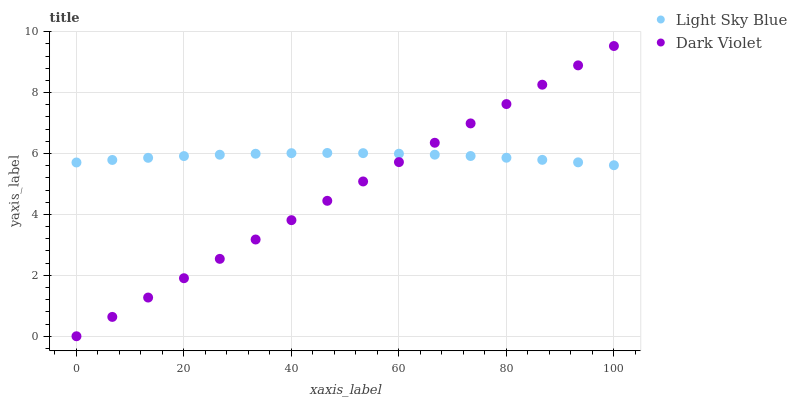Does Dark Violet have the minimum area under the curve?
Answer yes or no. Yes. Does Light Sky Blue have the maximum area under the curve?
Answer yes or no. Yes. Does Dark Violet have the maximum area under the curve?
Answer yes or no. No. Is Dark Violet the smoothest?
Answer yes or no. Yes. Is Light Sky Blue the roughest?
Answer yes or no. Yes. Is Dark Violet the roughest?
Answer yes or no. No. Does Dark Violet have the lowest value?
Answer yes or no. Yes. Does Dark Violet have the highest value?
Answer yes or no. Yes. Does Light Sky Blue intersect Dark Violet?
Answer yes or no. Yes. Is Light Sky Blue less than Dark Violet?
Answer yes or no. No. Is Light Sky Blue greater than Dark Violet?
Answer yes or no. No. 